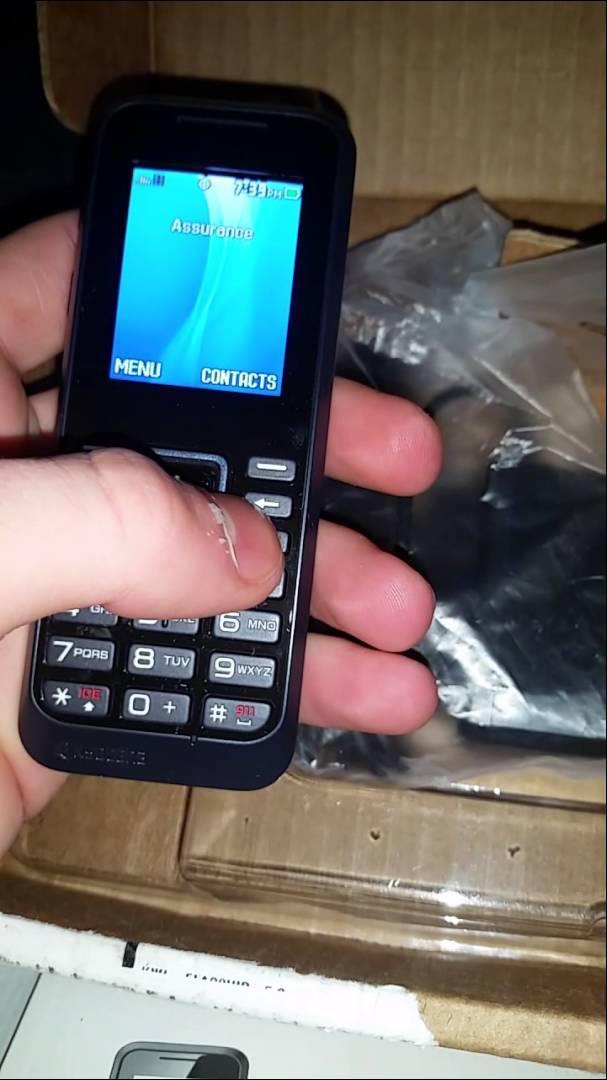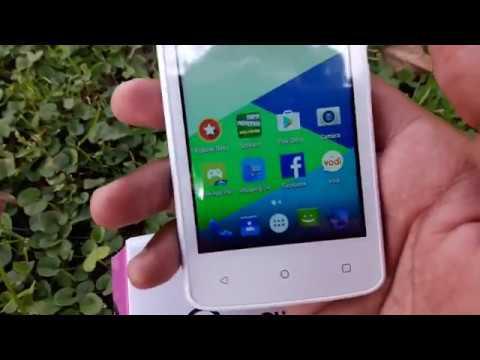The first image is the image on the left, the second image is the image on the right. Assess this claim about the two images: "A phone is being held by a person in each photo.". Correct or not? Answer yes or no. Yes. 